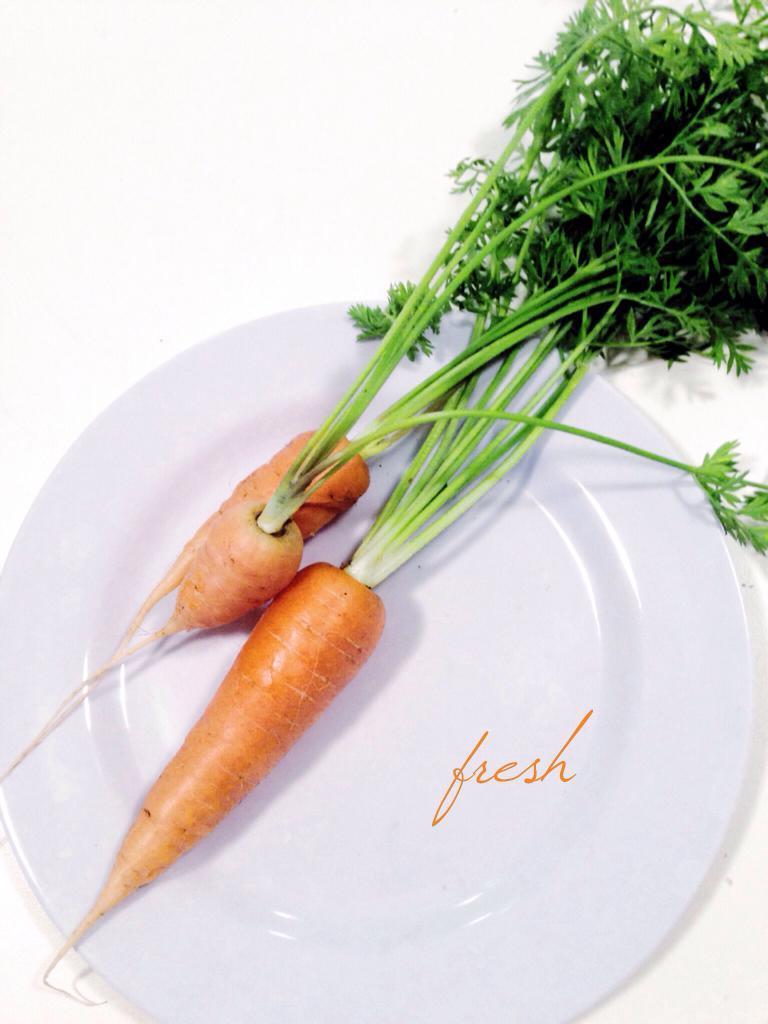Can you describe this image briefly? In this image, we can see a plate, on the plate, we can see two carrots and green leaves. 